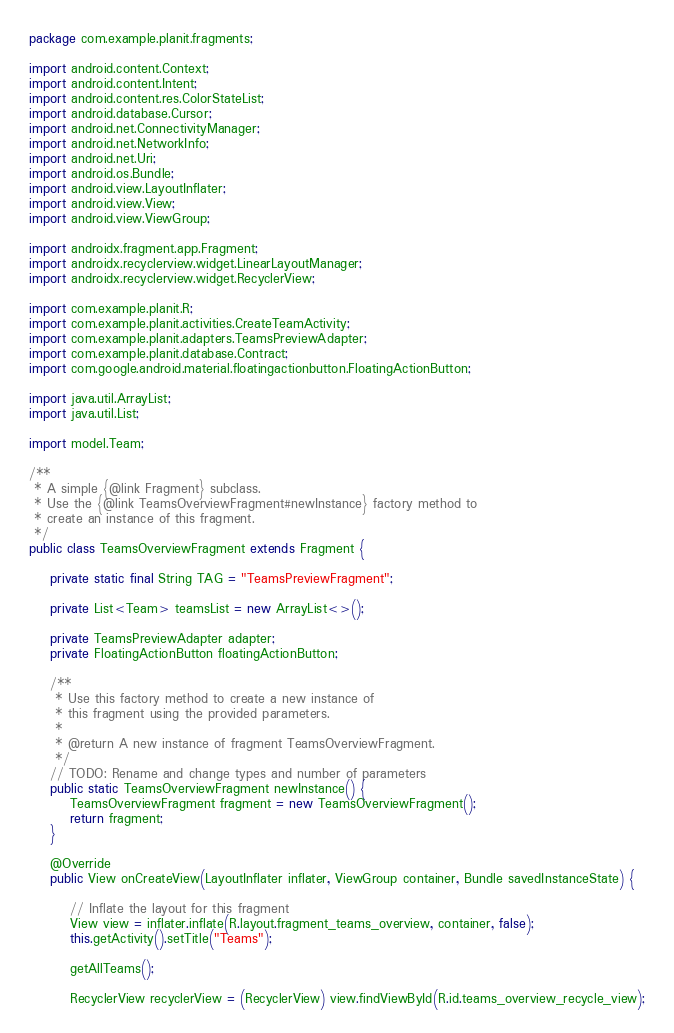Convert code to text. <code><loc_0><loc_0><loc_500><loc_500><_Java_>package com.example.planit.fragments;

import android.content.Context;
import android.content.Intent;
import android.content.res.ColorStateList;
import android.database.Cursor;
import android.net.ConnectivityManager;
import android.net.NetworkInfo;
import android.net.Uri;
import android.os.Bundle;
import android.view.LayoutInflater;
import android.view.View;
import android.view.ViewGroup;

import androidx.fragment.app.Fragment;
import androidx.recyclerview.widget.LinearLayoutManager;
import androidx.recyclerview.widget.RecyclerView;

import com.example.planit.R;
import com.example.planit.activities.CreateTeamActivity;
import com.example.planit.adapters.TeamsPreviewAdapter;
import com.example.planit.database.Contract;
import com.google.android.material.floatingactionbutton.FloatingActionButton;

import java.util.ArrayList;
import java.util.List;

import model.Team;

/**
 * A simple {@link Fragment} subclass.
 * Use the {@link TeamsOverviewFragment#newInstance} factory method to
 * create an instance of this fragment.
 */
public class TeamsOverviewFragment extends Fragment {

    private static final String TAG = "TeamsPreviewFragment";

    private List<Team> teamsList = new ArrayList<>();

    private TeamsPreviewAdapter adapter;
    private FloatingActionButton floatingActionButton;

    /**
     * Use this factory method to create a new instance of
     * this fragment using the provided parameters.
     *
     * @return A new instance of fragment TeamsOverviewFragment.
     */
    // TODO: Rename and change types and number of parameters
    public static TeamsOverviewFragment newInstance() {
        TeamsOverviewFragment fragment = new TeamsOverviewFragment();
        return fragment;
    }

    @Override
    public View onCreateView(LayoutInflater inflater, ViewGroup container, Bundle savedInstanceState) {

        // Inflate the layout for this fragment
        View view = inflater.inflate(R.layout.fragment_teams_overview, container, false);
        this.getActivity().setTitle("Teams");

        getAllTeams();

        RecyclerView recyclerView = (RecyclerView) view.findViewById(R.id.teams_overview_recycle_view);</code> 